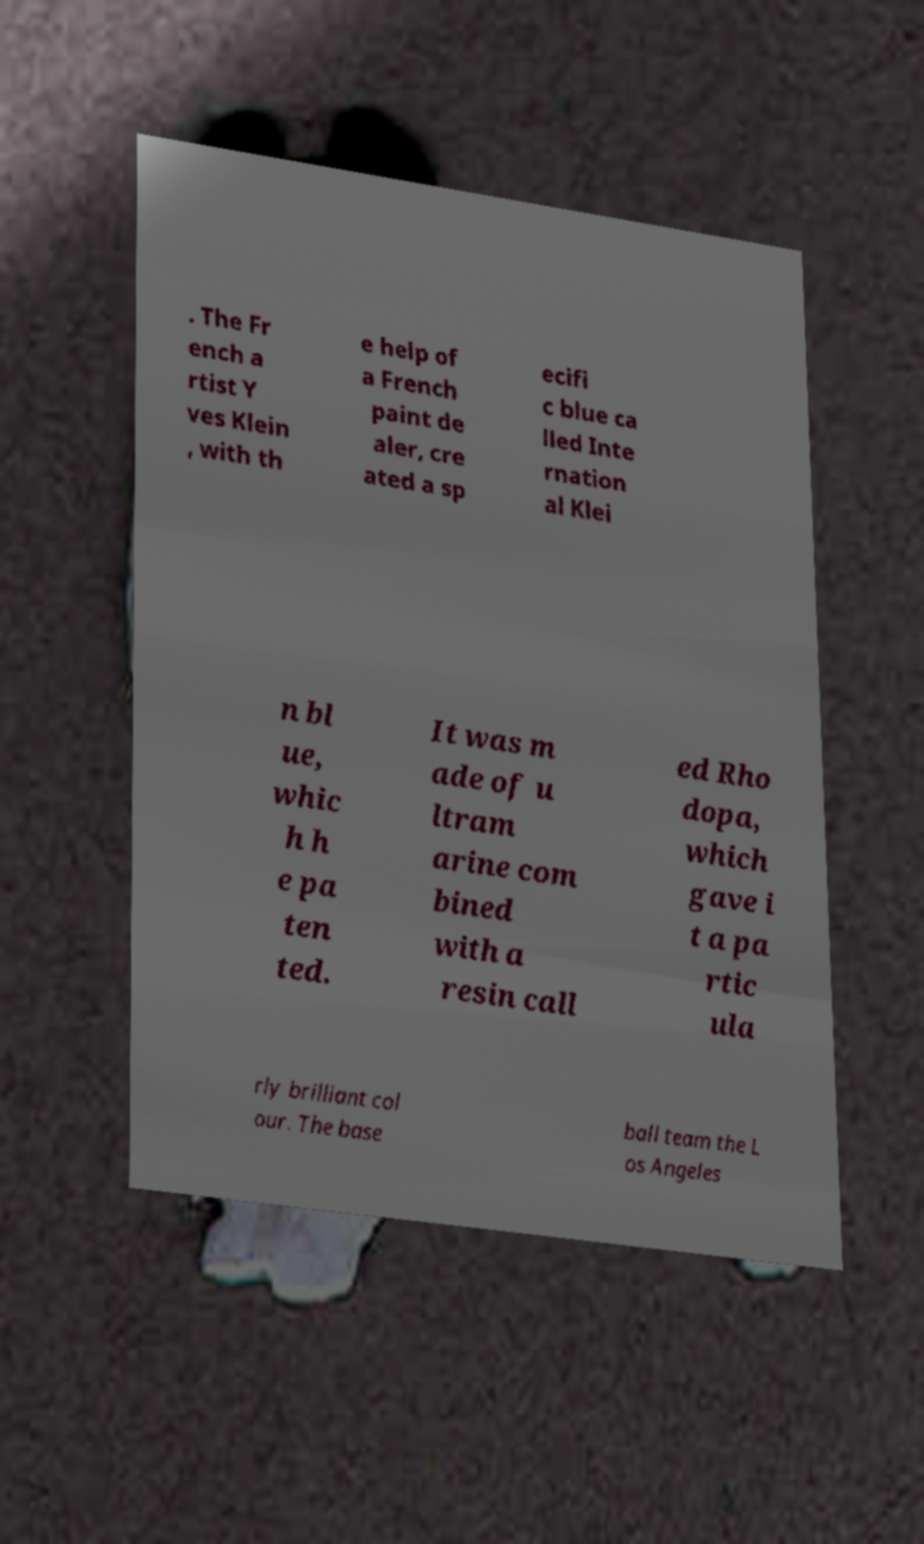Could you extract and type out the text from this image? . The Fr ench a rtist Y ves Klein , with th e help of a French paint de aler, cre ated a sp ecifi c blue ca lled Inte rnation al Klei n bl ue, whic h h e pa ten ted. It was m ade of u ltram arine com bined with a resin call ed Rho dopa, which gave i t a pa rtic ula rly brilliant col our. The base ball team the L os Angeles 